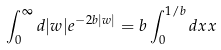<formula> <loc_0><loc_0><loc_500><loc_500>\int _ { 0 } ^ { \infty } d | w | e ^ { - 2 b | w | } = b \int _ { 0 } ^ { 1 / b } d x x</formula> 